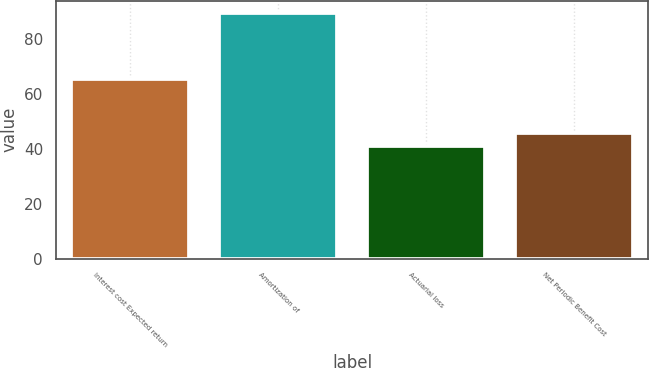<chart> <loc_0><loc_0><loc_500><loc_500><bar_chart><fcel>Interest cost Expected return<fcel>Amortization of<fcel>Actuarial loss<fcel>Net Periodic Benefit Cost<nl><fcel>65.5<fcel>89.6<fcel>41<fcel>45.86<nl></chart> 